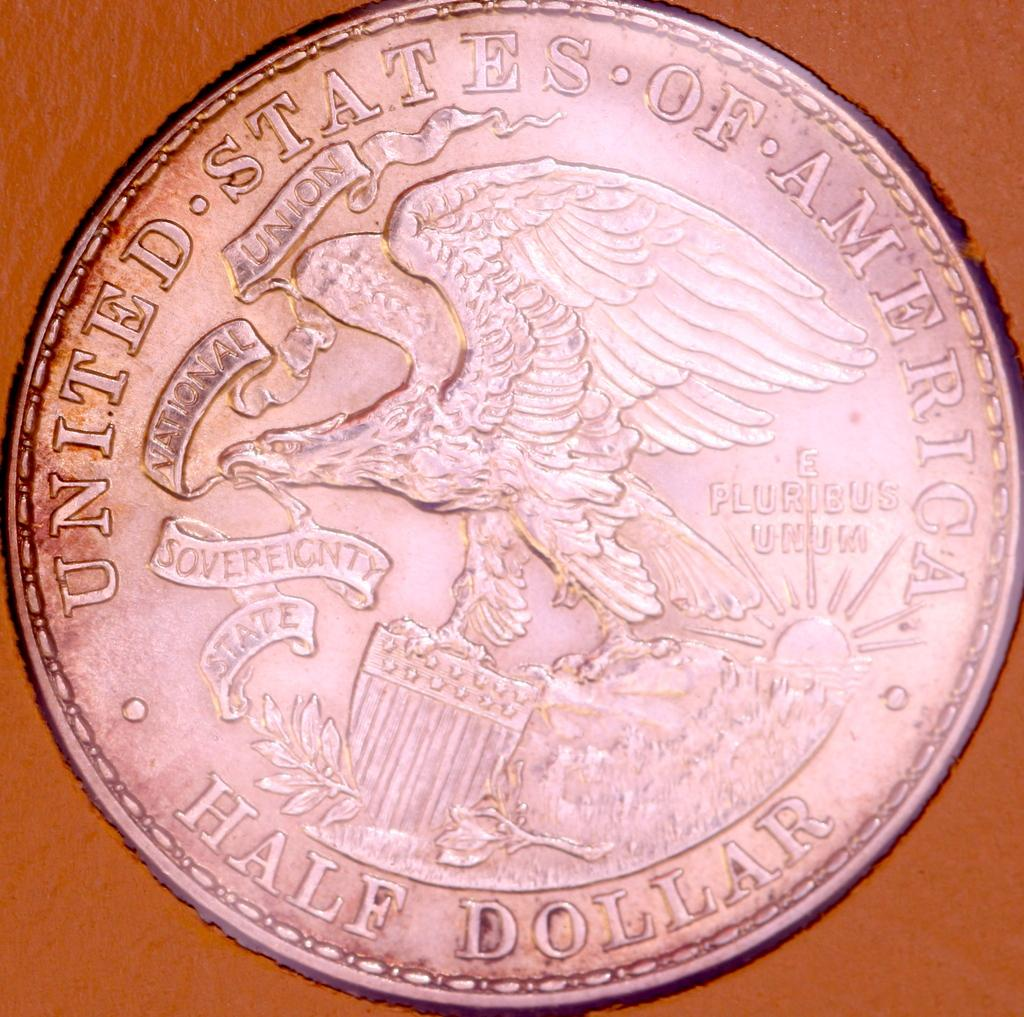Provide a one-sentence caption for the provided image. An old silver Unites States of America half dollar. 